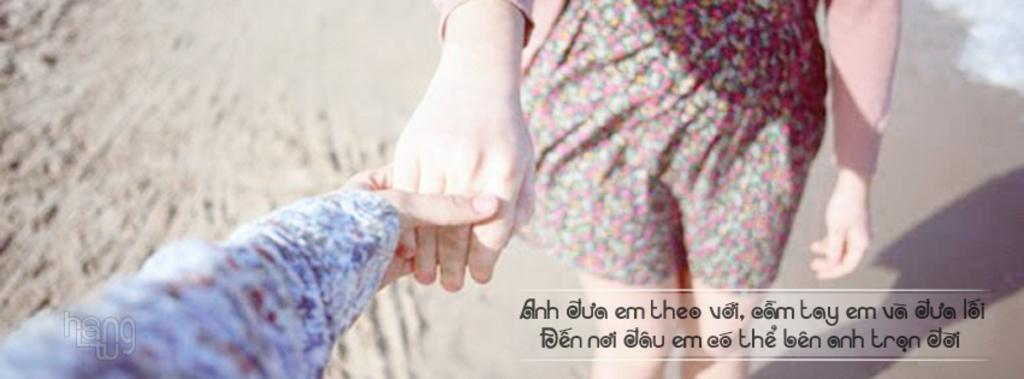How many people are in the image? There are two persons in the image. What is the relationship between the two people in the image? One person is holding the hand of the other person. What type of terrain is visible in the image? There is sand in the image. Are there any visible imperfections on the image? Yes, there are watermarks on the image. What type of kettle can be seen in the image? There is no kettle present in the image. What is the coil used for in the image? There is no coil present in the image. 